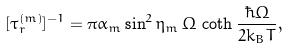<formula> <loc_0><loc_0><loc_500><loc_500>[ \tau _ { r } ^ { ( m ) } ] ^ { - 1 } = \pi \alpha _ { m } \sin ^ { 2 } \eta _ { m } \, \Omega \, \coth \frac { \hbar { \Omega } } { 2 k _ { B } T } ,</formula> 